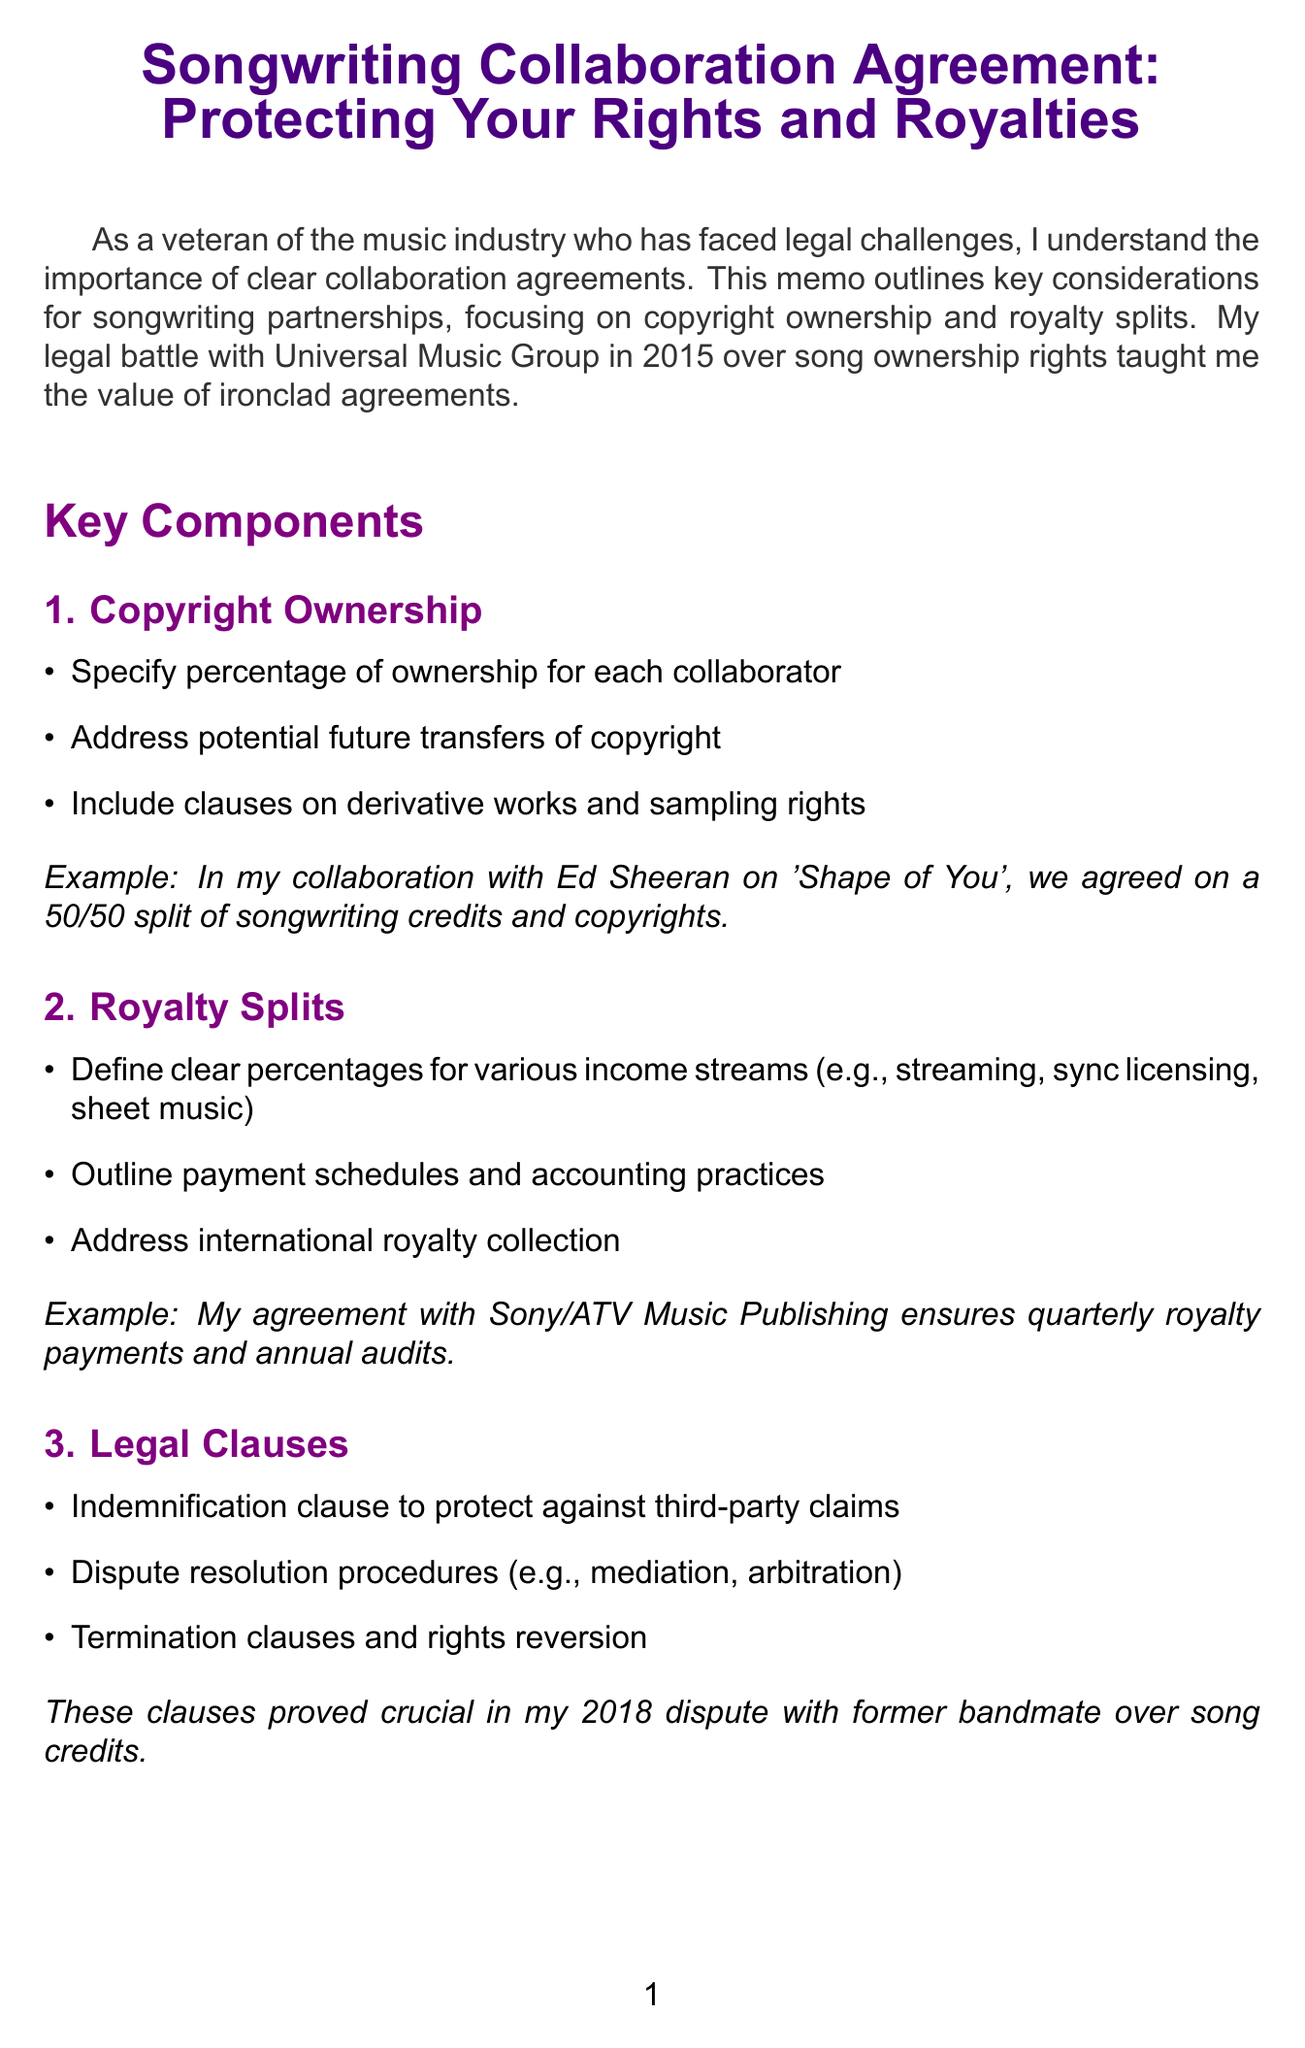What is the title of the memo? The title is presented clearly at the top of the document, highlighting the subject of the memo.
Answer: Songwriting Collaboration Agreement: Protecting Your Rights and Royalties Who is recommended for contract review? The memo suggests consulting a specific individual with expertise in music contracts to ensure thorough checks are done.
Answer: Donald Passman What royalty payment schedule is mentioned? The memo mentions how frequently royalties are scheduled to be paid according to an example agreement.
Answer: Quarterly What is a key component of copyright ownership discussed? The document lists specific considerations regarding ownership rights that collaborate should address in their agreement.
Answer: Specify percentage of ownership for each collaborator Which streaming platform is mentioned in relation to industry trends? The document refers to a popular platform that has influenced how royalties are calculated in the digital music space.
Answer: Spotify What legal clause helps protect against third-party claims? The memo outlines a specific type of provision included in songwriting agreements to safeguard collaborators from external disputes.
Answer: Indemnification clause What was a personal lesson learned from the author's legal battle? The author shares an experience that emphasizes the importance of having solid legal agreements in place for songwriting partnerships.
Answer: The value of ironclad agreements Which year did the author's battle with Universal Music Group occur? The document provides a specific year related to the author's previous legal conflict that had implications for song ownership rights.
Answer: 2015 